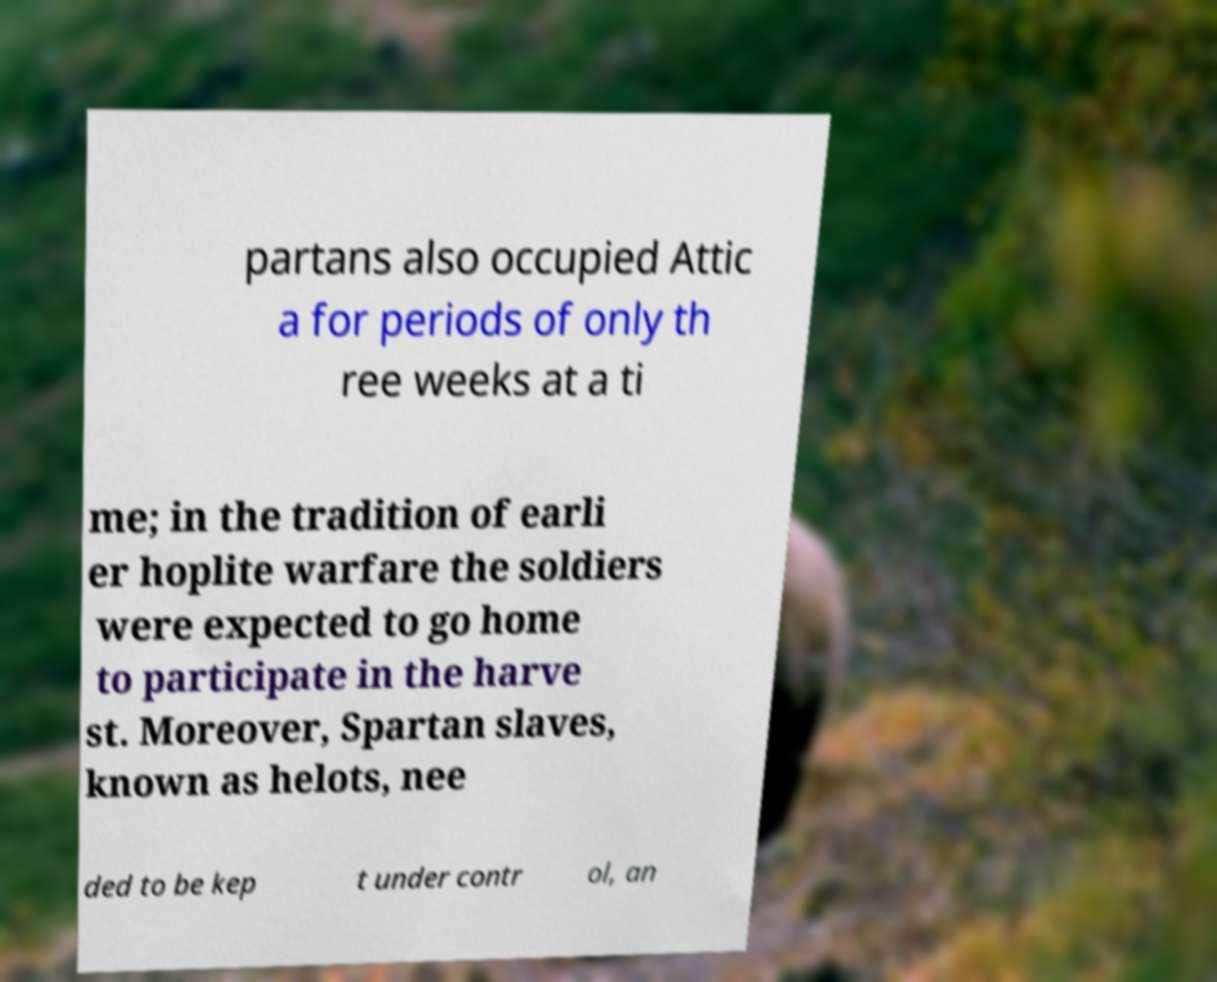I need the written content from this picture converted into text. Can you do that? partans also occupied Attic a for periods of only th ree weeks at a ti me; in the tradition of earli er hoplite warfare the soldiers were expected to go home to participate in the harve st. Moreover, Spartan slaves, known as helots, nee ded to be kep t under contr ol, an 